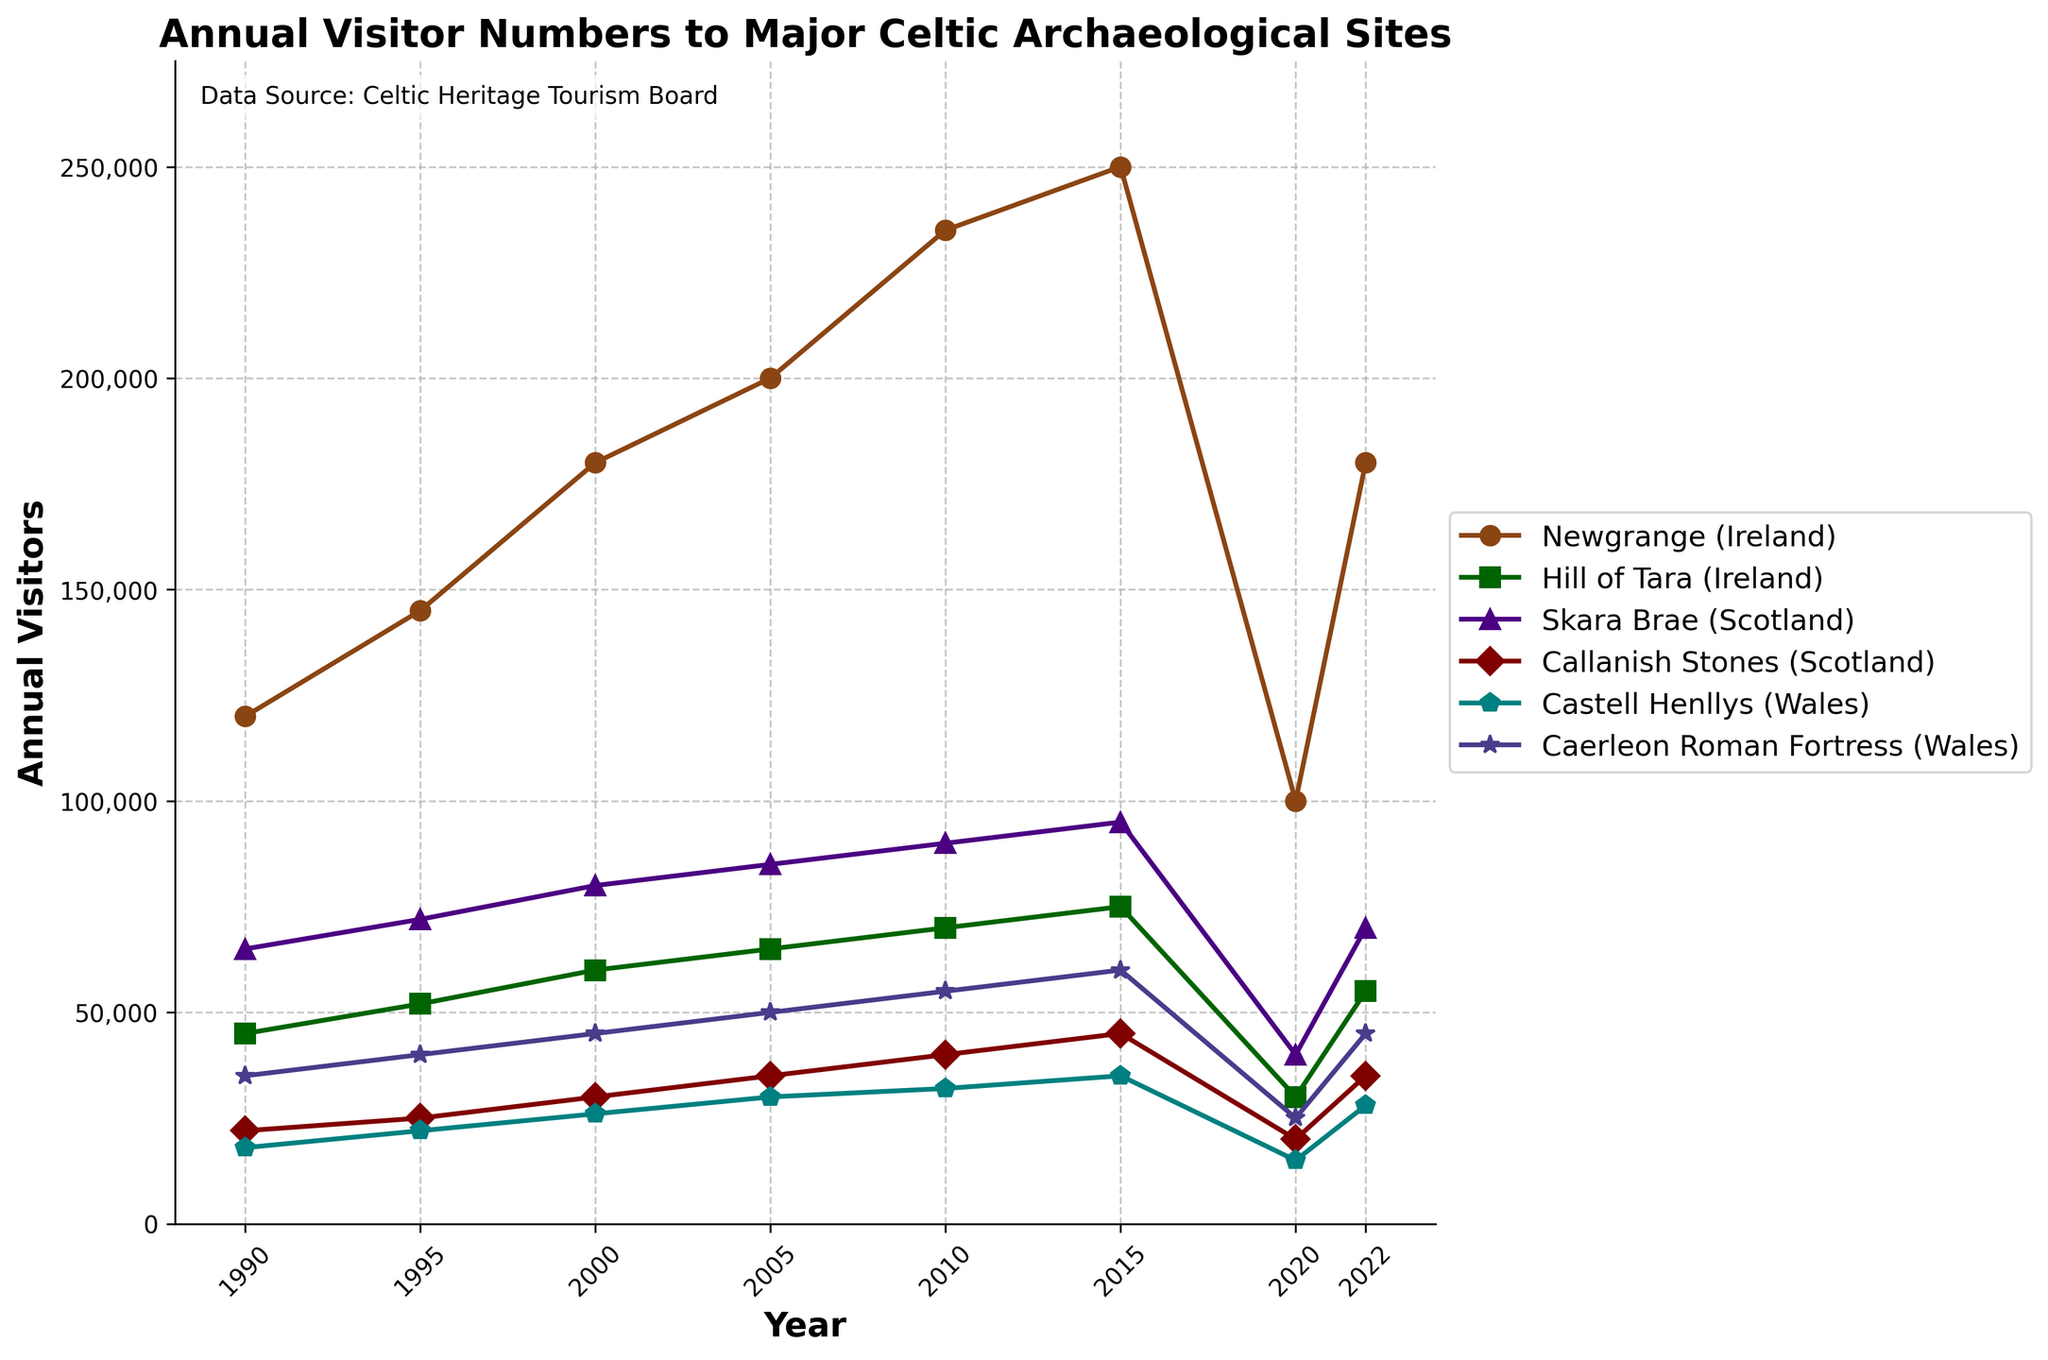What was the trend for visitor numbers to major Celtic archaeological sites in Ireland from 1990 to 2022? To determine the trend, observe the lines representing Newgrange and Hill of Tara over the years from 1990 to 2022. Focus on the direction of the lines and identify key changes. Both sites show an overall increasing trend with a notable dip around 2020. Newgrange has a sharper increase compared to Hill of Tara.
Answer: Increasing with a dip in 2020 Which site in Scotland saw the highest increase in annual visitors from 1990 to 2022? Compare the visitor numbers for Skara Brae and Callanish Stones in 1990 and then again in 2022. Calculate the difference for each site's starting and ending values to find the increase. Skara Brae increased from 65,000 to 70,000, resulting in an increase of 5,000. Callanish Stones increased from 22,000 to 35,000, increasing by 13,000.
Answer: Callanish Stones How did visitor numbers to Castell Henllys and Caerleon Roman Fortress in Wales compare in 2020? Look at the values for Castell Henllys and Caerleon Roman Fortress in the year 2020. Castell Henllys had 15,000 visitors and Caerleon Roman Fortress had 25,000 visitors.
Answer: Caerleon Roman Fortress had more visitors What is the average number of visitors to Skara Brae in Scotland across all the given years? Sum the visitors to Skara Brae for each listed year and divide by the total number of years. (65,000 + 72,000 + 80,000 + 85,000 + 90,000 + 95,000 + 40,000 + 70,000) / 8 gives an average. The total is 597,000, which averages to 74,625 visitors.
Answer: 74,625 What was the difference in visitor numbers between the year 2020 and 2022 for Newgrange in Ireland? Find the visitor numbers for Newgrange in 2020 and 2022. Then, subtract the 2020 value from the 2022 value. 180,000 in 2022 minus 100,000 in 2020 results in a difference of 80,000.
Answer: 80,000 By observing the colors and markers, which sites experienced a decrease in visitors from 2015 to 2020? Check the colors and markers for each site and track their visitor numbers from 2015 to 2020. Newgrange, Hill of Tara, Skara Brae, Callanish Stones, Castell Henllys, and Caerleon Roman Fortress all show a decrease in visitor numbers during this period.
Answer: All sites Which archaeological site had the least annual visitors in 2000? Look at the visitor numbers for all the sites in the year 2000. Compare the values to determine the smallest number. Castell Henllys had 26,000 visitors, the least among all the sites.
Answer: Castell Henllys What was the cumulative number of visitors to all the Celtic archaeological sites in 2015? Add the visitor numbers for all sites in 2015. (250,000 + 75,000 + 95,000 + 45,000 + 35,000 + 60,000) equals 560,000.
Answer: 560,000 